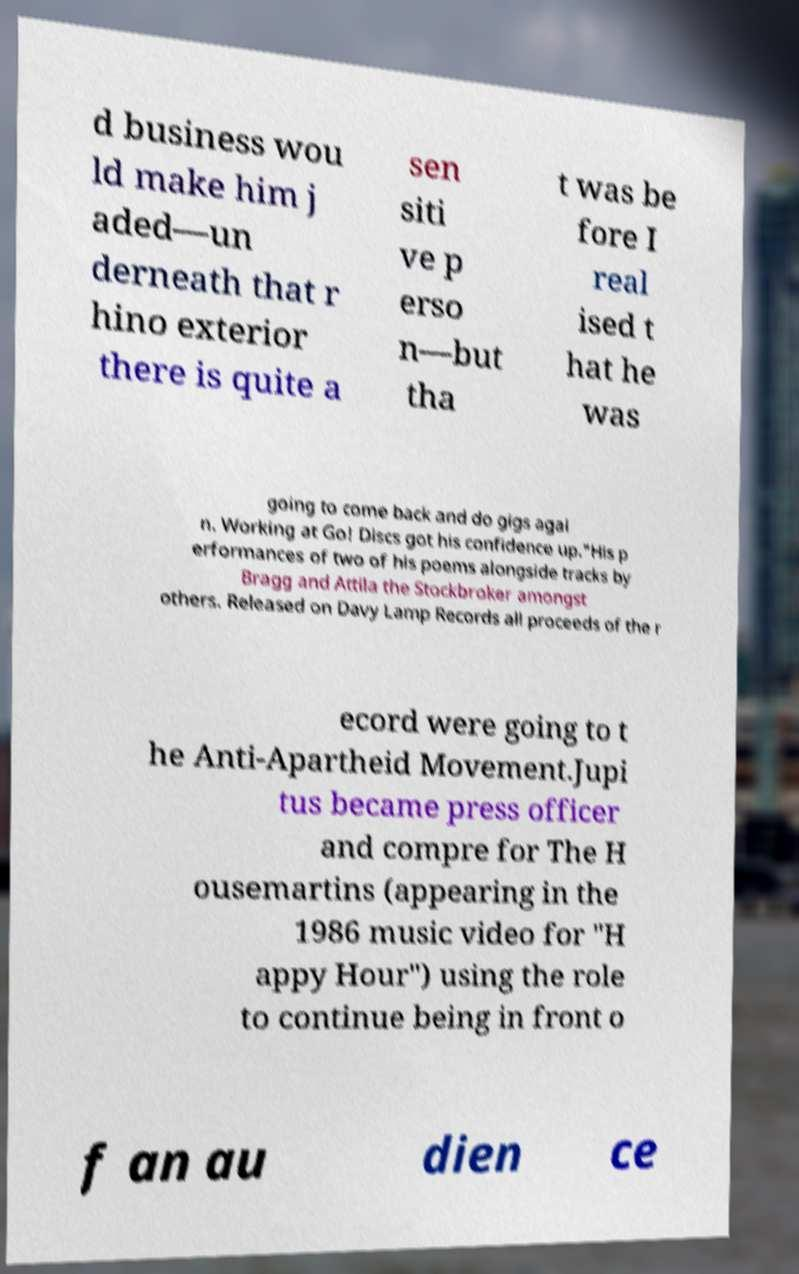There's text embedded in this image that I need extracted. Can you transcribe it verbatim? d business wou ld make him j aded—un derneath that r hino exterior there is quite a sen siti ve p erso n—but tha t was be fore I real ised t hat he was going to come back and do gigs agai n. Working at Go! Discs got his confidence up."His p erformances of two of his poems alongside tracks by Bragg and Attila the Stockbroker amongst others. Released on Davy Lamp Records all proceeds of the r ecord were going to t he Anti-Apartheid Movement.Jupi tus became press officer and compre for The H ousemartins (appearing in the 1986 music video for "H appy Hour") using the role to continue being in front o f an au dien ce 